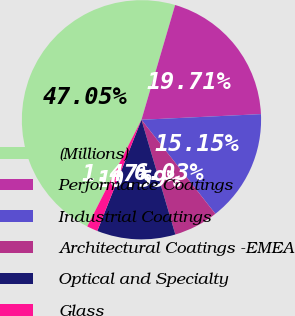Convert chart. <chart><loc_0><loc_0><loc_500><loc_500><pie_chart><fcel>(Millions)<fcel>Performance Coatings<fcel>Industrial Coatings<fcel>Architectural Coatings -EMEA<fcel>Optical and Specialty<fcel>Glass<nl><fcel>47.05%<fcel>19.71%<fcel>15.15%<fcel>6.03%<fcel>10.59%<fcel>1.47%<nl></chart> 